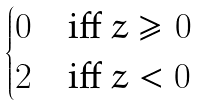<formula> <loc_0><loc_0><loc_500><loc_500>\begin{cases} 0 & \text {iff } z \geq 0 \\ 2 & \text {iff } z < 0 \end{cases}</formula> 